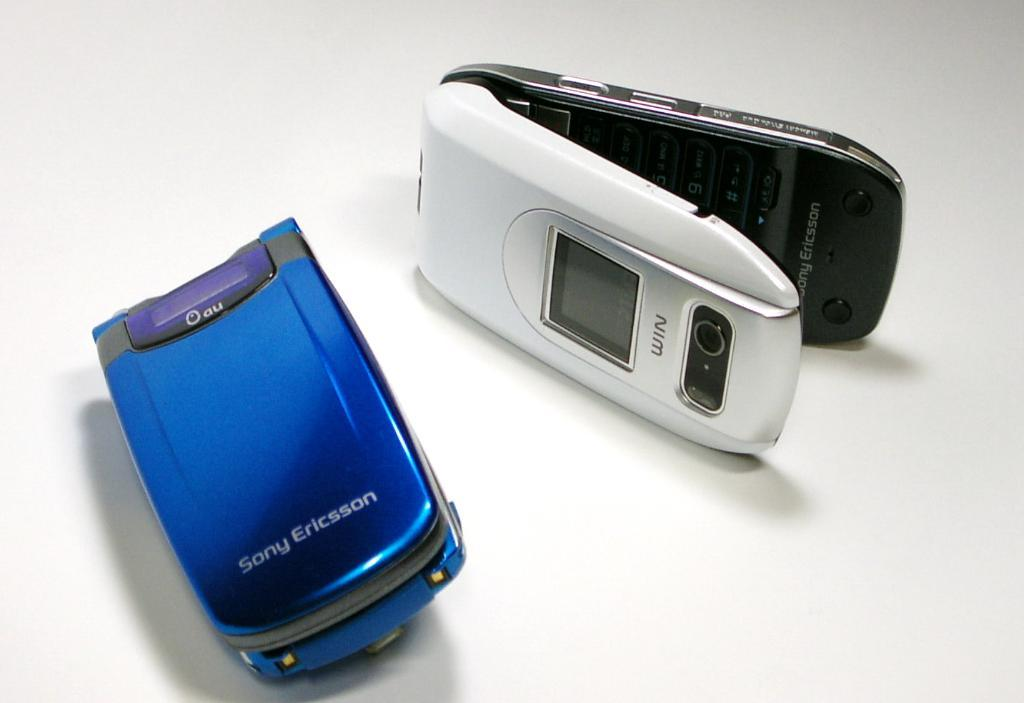<image>
Relay a brief, clear account of the picture shown. A blue Sony Ericsson flip phone sits next to another phone. 